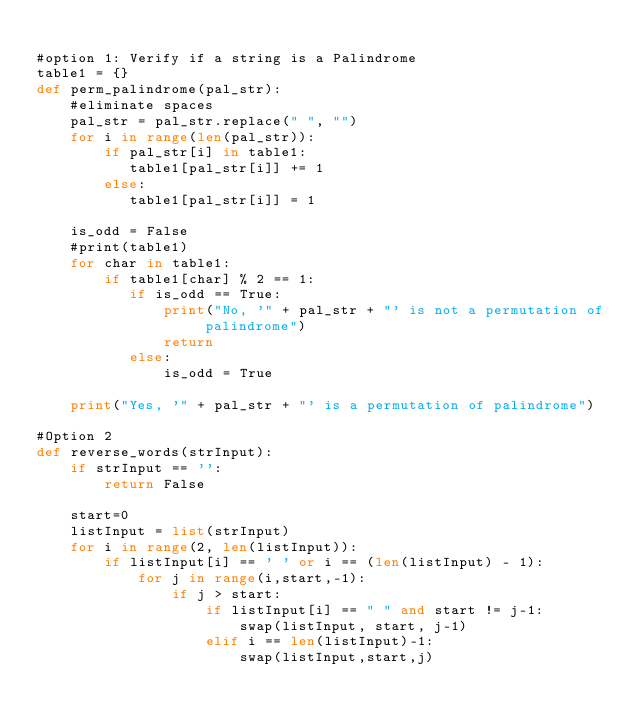Convert code to text. <code><loc_0><loc_0><loc_500><loc_500><_Python_>
#option 1: Verify if a string is a Palindrome
table1 = {}
def perm_palindrome(pal_str):
    #eliminate spaces
    pal_str = pal_str.replace(" ", "")
    for i in range(len(pal_str)):
        if pal_str[i] in table1:
           table1[pal_str[i]] += 1
        else:
           table1[pal_str[i]] = 1

    is_odd = False
    #print(table1)
    for char in table1:
        if table1[char] % 2 == 1:
           if is_odd == True:
               print("No, '" + pal_str + "' is not a permutation of palindrome")
               return
           else:
               is_odd = True

    print("Yes, '" + pal_str + "' is a permutation of palindrome")

#Option 2
def reverse_words(strInput):
    if strInput == '':
        return False

    start=0
    listInput = list(strInput)
    for i in range(2, len(listInput)):   
        if listInput[i] == ' ' or i == (len(listInput) - 1):
            for j in range(i,start,-1):               
                if j > start:
                    if listInput[i] == " " and start != j-1:
                        swap(listInput, start, j-1) 
                    elif i == len(listInput)-1:
                        swap(listInput,start,j)</code> 